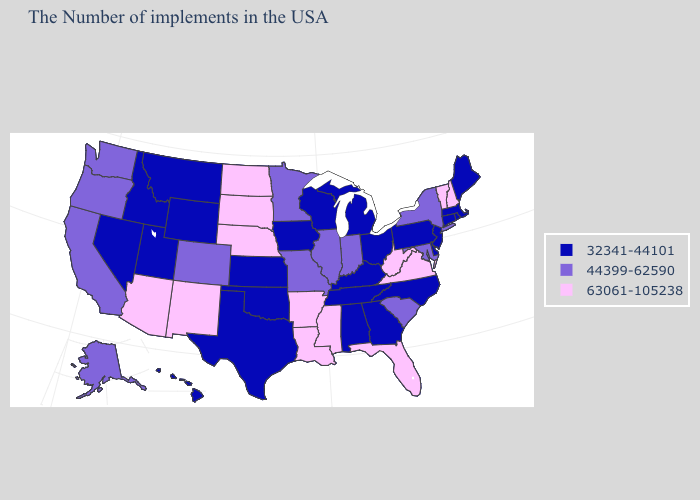What is the value of Utah?
Short answer required. 32341-44101. Among the states that border Connecticut , does Rhode Island have the highest value?
Concise answer only. No. What is the highest value in the USA?
Concise answer only. 63061-105238. Name the states that have a value in the range 44399-62590?
Give a very brief answer. New York, Maryland, South Carolina, Indiana, Illinois, Missouri, Minnesota, Colorado, California, Washington, Oregon, Alaska. Name the states that have a value in the range 32341-44101?
Answer briefly. Maine, Massachusetts, Rhode Island, Connecticut, New Jersey, Delaware, Pennsylvania, North Carolina, Ohio, Georgia, Michigan, Kentucky, Alabama, Tennessee, Wisconsin, Iowa, Kansas, Oklahoma, Texas, Wyoming, Utah, Montana, Idaho, Nevada, Hawaii. Name the states that have a value in the range 63061-105238?
Be succinct. New Hampshire, Vermont, Virginia, West Virginia, Florida, Mississippi, Louisiana, Arkansas, Nebraska, South Dakota, North Dakota, New Mexico, Arizona. How many symbols are there in the legend?
Answer briefly. 3. What is the lowest value in the South?
Short answer required. 32341-44101. What is the value of Mississippi?
Short answer required. 63061-105238. What is the value of South Dakota?
Answer briefly. 63061-105238. What is the value of North Dakota?
Quick response, please. 63061-105238. Name the states that have a value in the range 44399-62590?
Write a very short answer. New York, Maryland, South Carolina, Indiana, Illinois, Missouri, Minnesota, Colorado, California, Washington, Oregon, Alaska. Name the states that have a value in the range 44399-62590?
Write a very short answer. New York, Maryland, South Carolina, Indiana, Illinois, Missouri, Minnesota, Colorado, California, Washington, Oregon, Alaska. Does Arizona have the highest value in the West?
Quick response, please. Yes. 